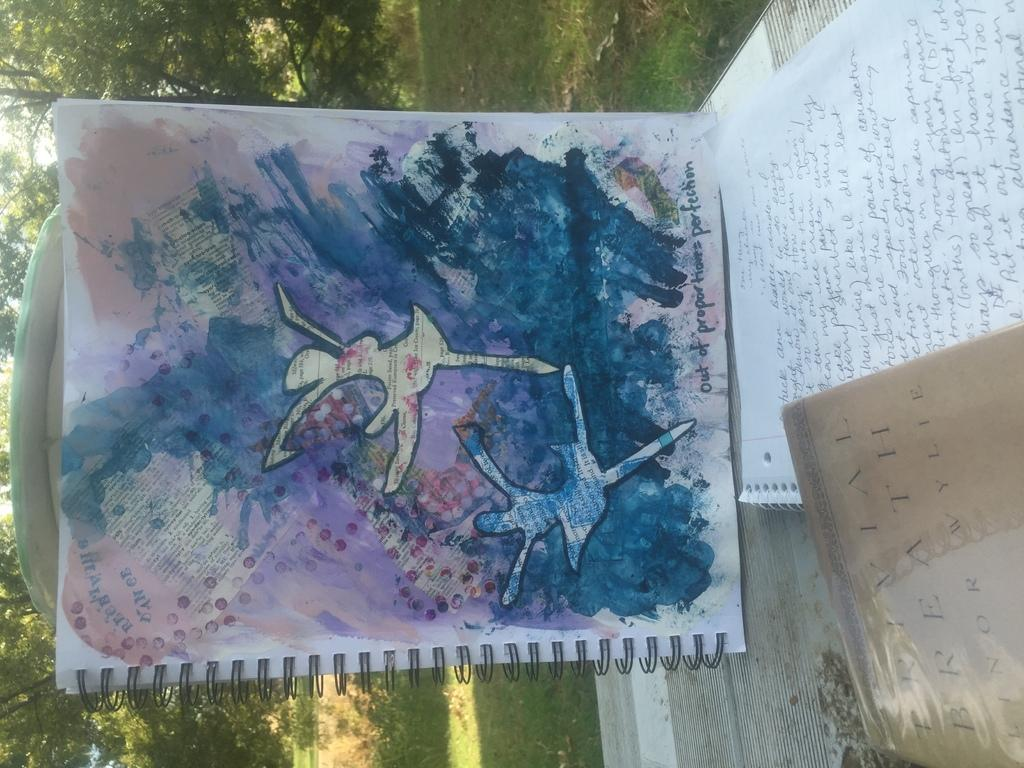What object is present in the image that can be read or studied? There is a book in the image. What is unique about the book's appearance? The book has a painting on it. What activity are the two figures in the painting engaged in? The painting depicts two girls dancing. What type of paper can be seen in the image? There is no paper visible in the image; the focus is on the book with a painting on it. 